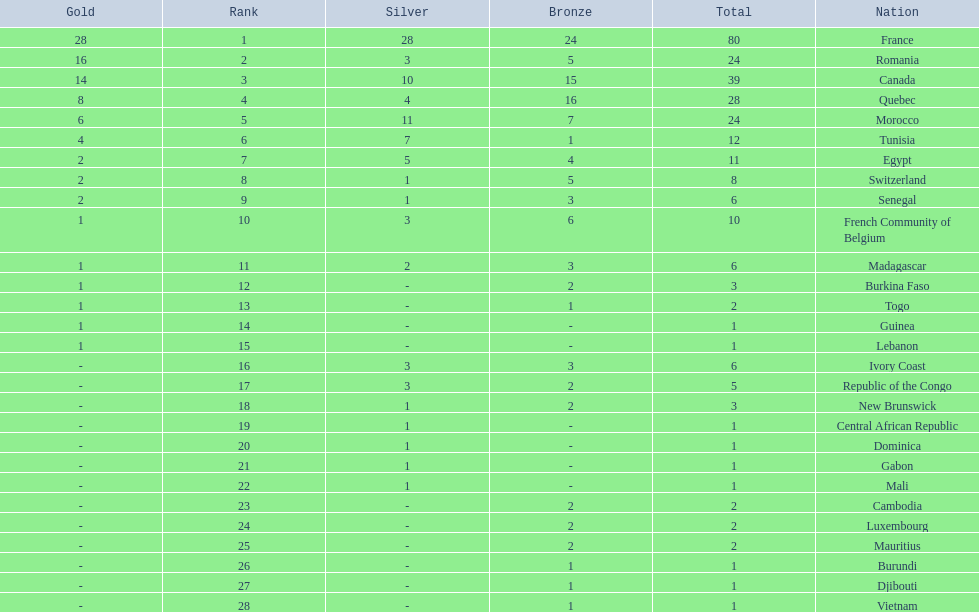How many more medals did egypt win than ivory coast? 5. 